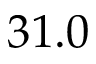Convert formula to latex. <formula><loc_0><loc_0><loc_500><loc_500>3 1 . 0</formula> 